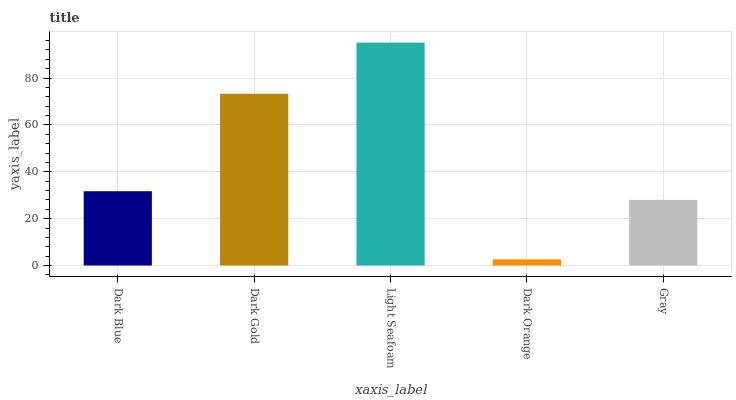Is Dark Orange the minimum?
Answer yes or no. Yes. Is Light Seafoam the maximum?
Answer yes or no. Yes. Is Dark Gold the minimum?
Answer yes or no. No. Is Dark Gold the maximum?
Answer yes or no. No. Is Dark Gold greater than Dark Blue?
Answer yes or no. Yes. Is Dark Blue less than Dark Gold?
Answer yes or no. Yes. Is Dark Blue greater than Dark Gold?
Answer yes or no. No. Is Dark Gold less than Dark Blue?
Answer yes or no. No. Is Dark Blue the high median?
Answer yes or no. Yes. Is Dark Blue the low median?
Answer yes or no. Yes. Is Gray the high median?
Answer yes or no. No. Is Dark Orange the low median?
Answer yes or no. No. 